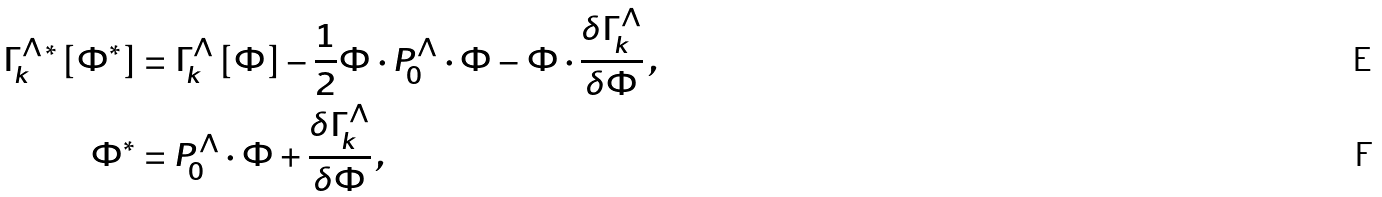<formula> <loc_0><loc_0><loc_500><loc_500>\Gamma ^ { \Lambda \, * } _ { k } \left [ \Phi ^ { * } \right ] & = \Gamma ^ { \Lambda } _ { k } \left [ \Phi \right ] - \frac { 1 } { 2 } \Phi \cdot P ^ { \Lambda } _ { 0 } \cdot \Phi - \Phi \cdot \frac { \delta \Gamma ^ { \Lambda } _ { k } } { \delta \Phi } \, , \\ \Phi ^ { * } & = P ^ { \Lambda } _ { 0 } \cdot \Phi + \frac { \delta \Gamma ^ { \Lambda } _ { k } } { \delta \Phi } \, ,</formula> 